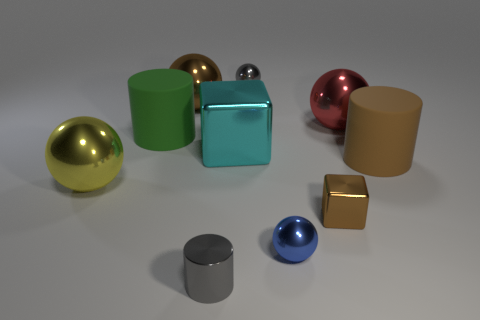There is a metallic sphere behind the brown shiny thing that is on the left side of the gray shiny object that is in front of the tiny cube; what size is it?
Give a very brief answer. Small. The sphere that is the same color as the small metal cylinder is what size?
Provide a short and direct response. Small. How many objects are big blue matte objects or small balls?
Your answer should be very brief. 2. The shiny thing that is both left of the tiny blue shiny sphere and in front of the small brown block has what shape?
Give a very brief answer. Cylinder. There is a cyan object; is its shape the same as the brown object that is in front of the big yellow metallic sphere?
Your answer should be compact. Yes. There is a big brown rubber cylinder; are there any tiny gray metallic cylinders behind it?
Your answer should be compact. No. What is the material of the sphere that is the same color as the shiny cylinder?
Give a very brief answer. Metal. What number of spheres are either big cyan shiny objects or big brown matte objects?
Offer a terse response. 0. Does the small blue object have the same shape as the cyan object?
Your answer should be compact. No. There is a matte cylinder to the left of the large brown cylinder; what size is it?
Make the answer very short. Large. 